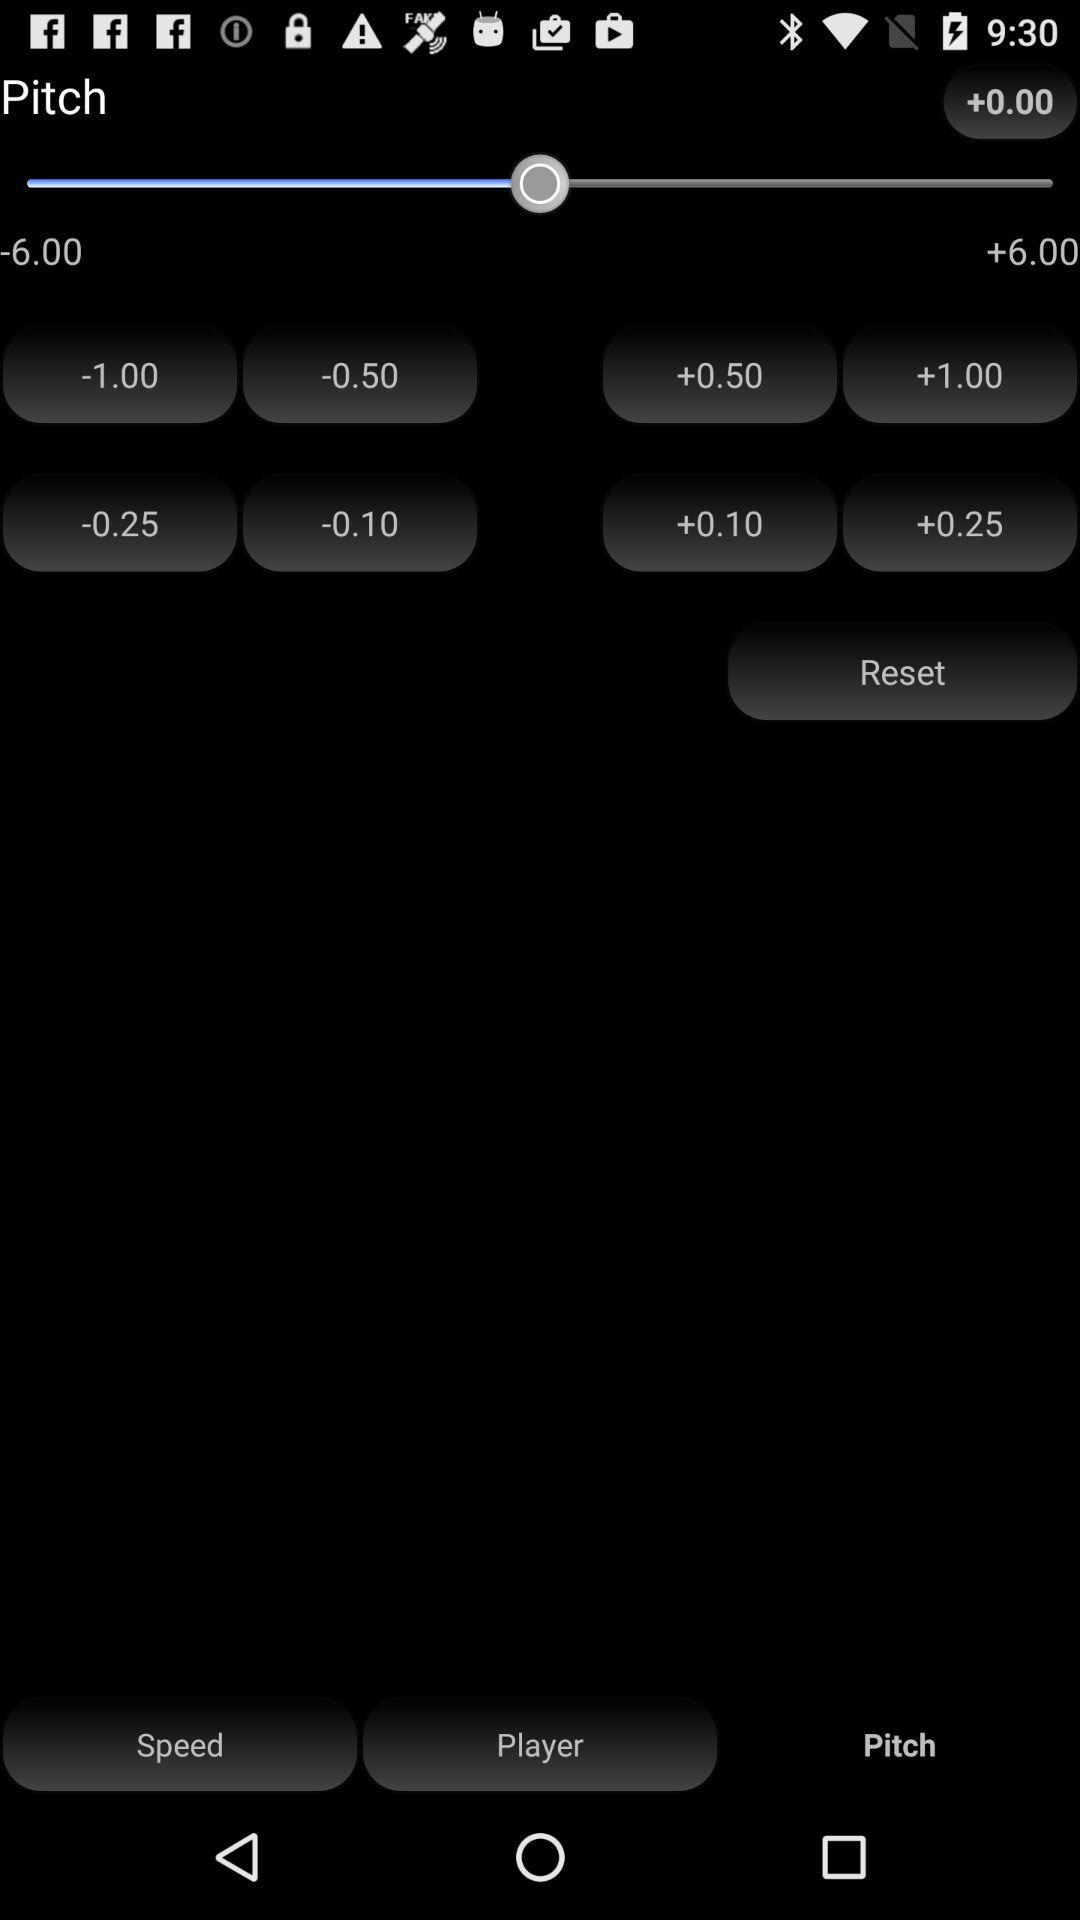What is the selected option? The selected option is "Pitch". 